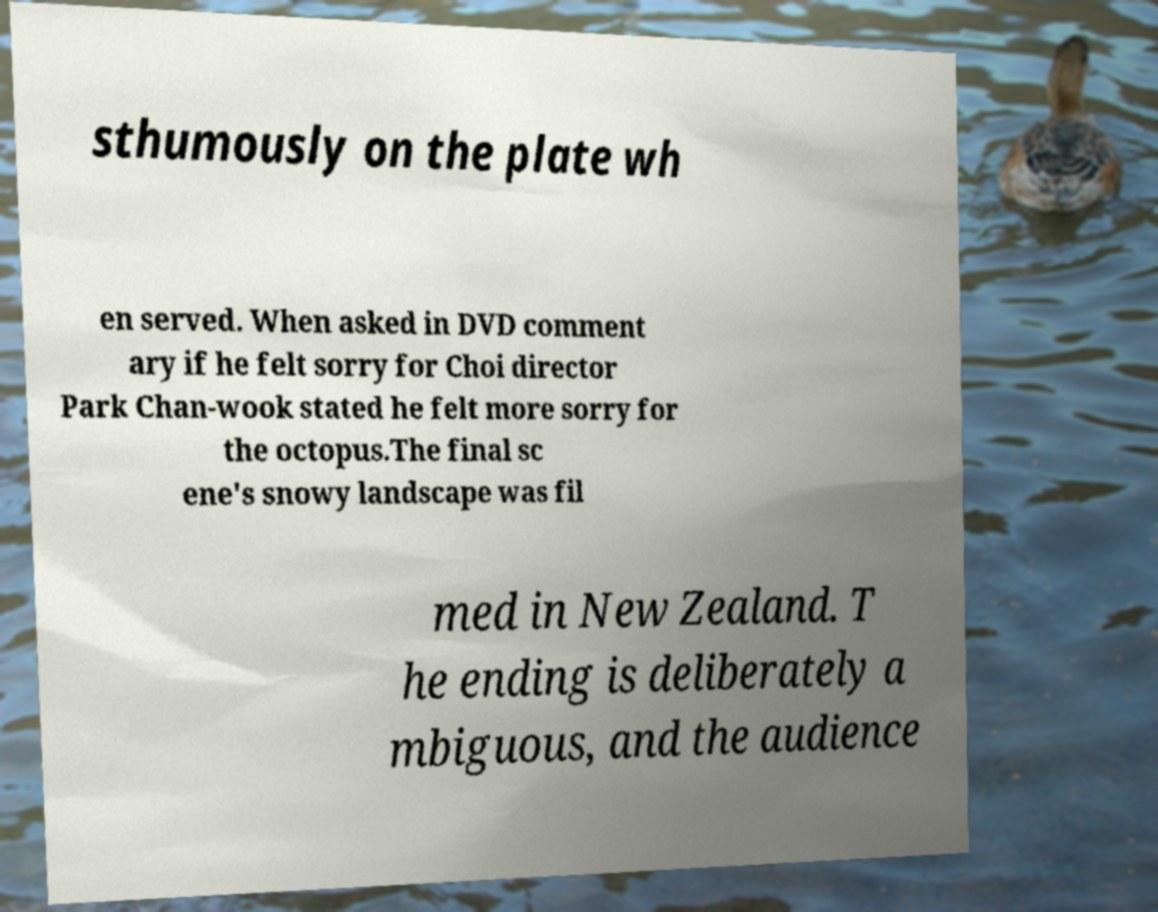There's text embedded in this image that I need extracted. Can you transcribe it verbatim? sthumously on the plate wh en served. When asked in DVD comment ary if he felt sorry for Choi director Park Chan-wook stated he felt more sorry for the octopus.The final sc ene's snowy landscape was fil med in New Zealand. T he ending is deliberately a mbiguous, and the audience 